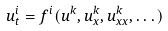<formula> <loc_0><loc_0><loc_500><loc_500>u ^ { i } _ { t } = f ^ { i } ( u ^ { k } , u ^ { k } _ { x } , u ^ { k } _ { x x } , \dots )</formula> 